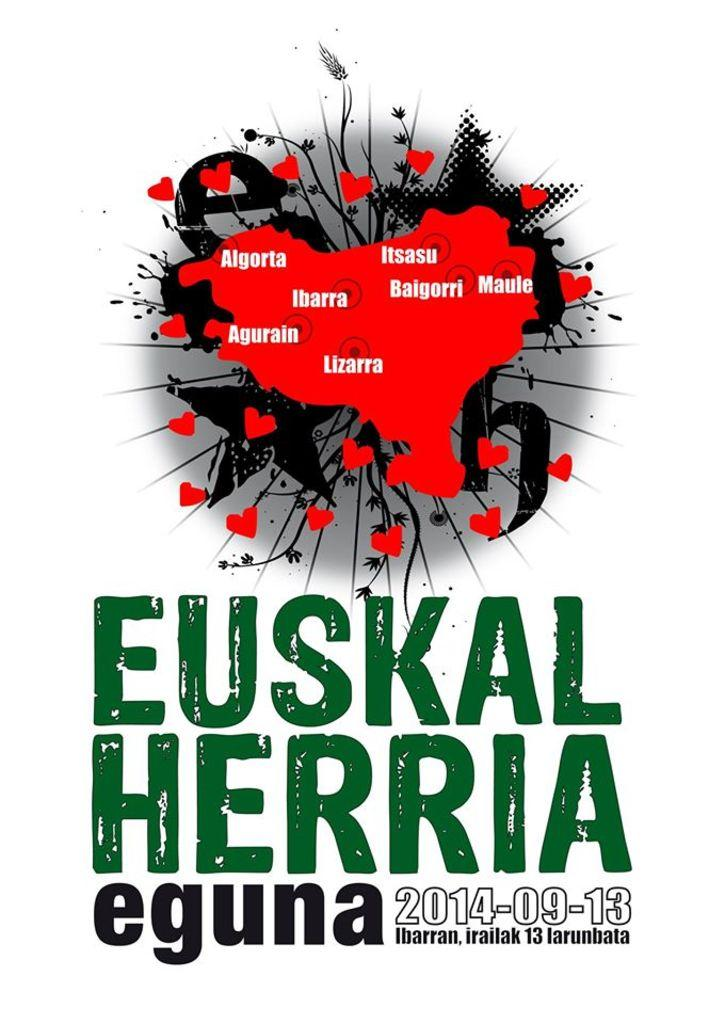<image>
Summarize the visual content of the image. A poster for an event called Euskal Herria Eguna with the date 2014-09-13. 